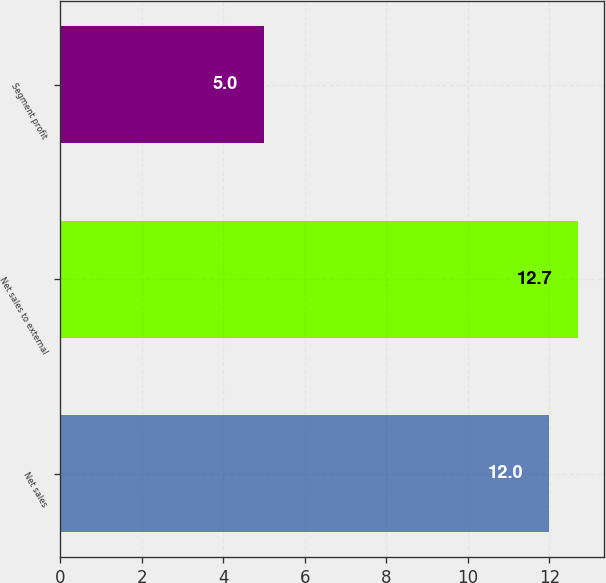<chart> <loc_0><loc_0><loc_500><loc_500><bar_chart><fcel>Net sales<fcel>Net sales to external<fcel>Segment profit<nl><fcel>12<fcel>12.7<fcel>5<nl></chart> 